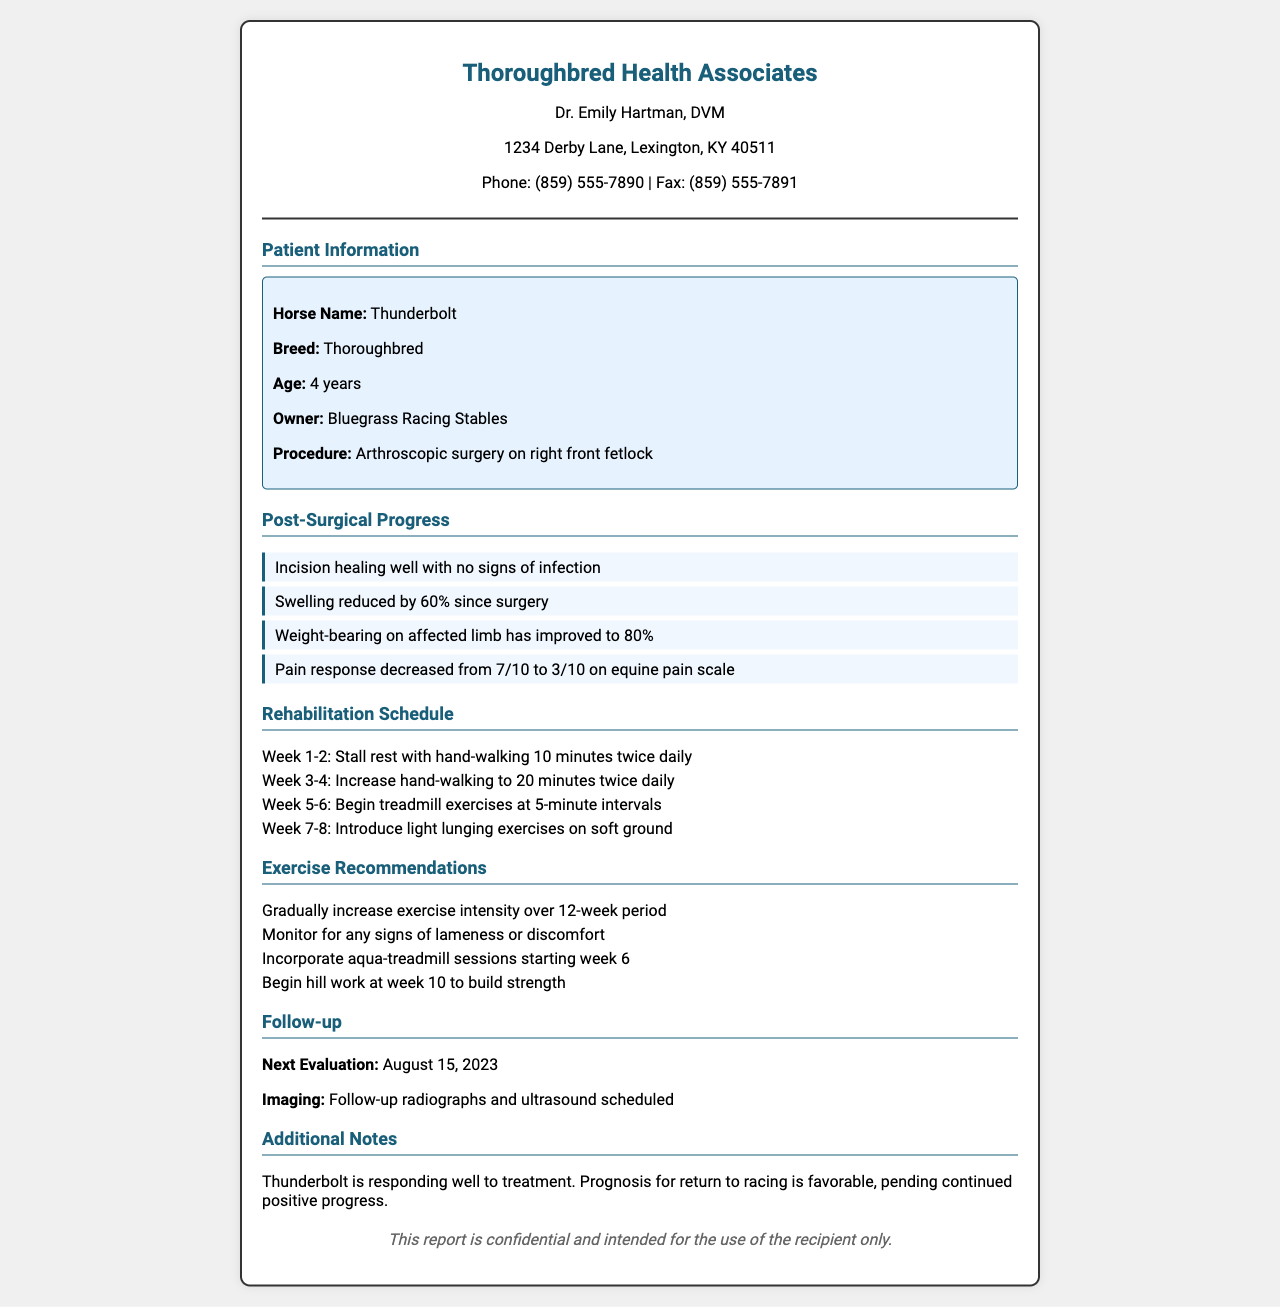What is the horse's name? The horse's name is explicitly mentioned in the patient information section.
Answer: Thunderbolt What procedure was performed? The specific procedure is stated under the patient information header.
Answer: Arthroscopic surgery on right front fetlock What is the current weight-bearing percentage on the affected limb? The document lists the percentage of weight-bearing the horse can currently manage.
Answer: 80% When is the next evaluation scheduled? The date for the next evaluation is clearly stated in the follow-up section of the document.
Answer: August 15, 2023 What is the recommended exercise at week 7-8? The rehabilitation schedule outlines the recommended exercise for that timeframe.
Answer: Light lunging exercises on soft ground What is the pain response score currently? The document includes the horse's pain response score after surgery.
Answer: 3/10 What percentage has swelling reduced by since surgery? The post-surgical progress section specifies the percentage of swelling reduction.
Answer: 60% What is the prognosis for return to racing? The document offers a summary of the horse's prognosis regarding returning to racing.
Answer: Favorable 